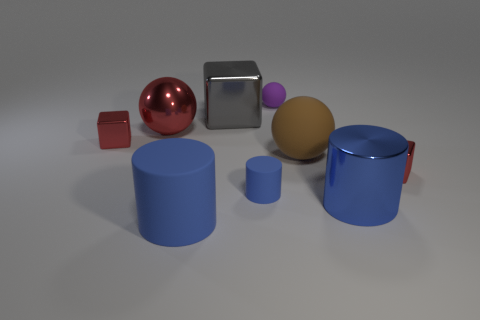What is the texture of the objects? The objects exhibit a variety of textures. The cubes and spheres have a smooth and reflective surface, suggesting a polished material, potentially metallic for the silver cube and red sphere. In contrast, the blue cylinders appear to have a matte finish, indicative of a non-reflective, likely more tactile texture. 